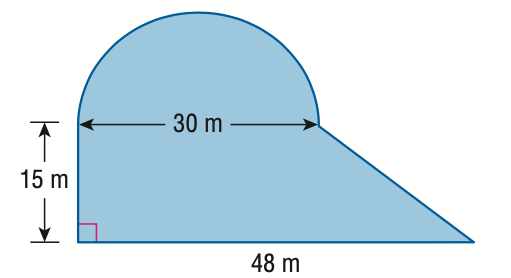Question: Find the area of the figure.
Choices:
A. 938.4
B. 1291.9
C. 1523.4
D. 1876.9
Answer with the letter. Answer: A 